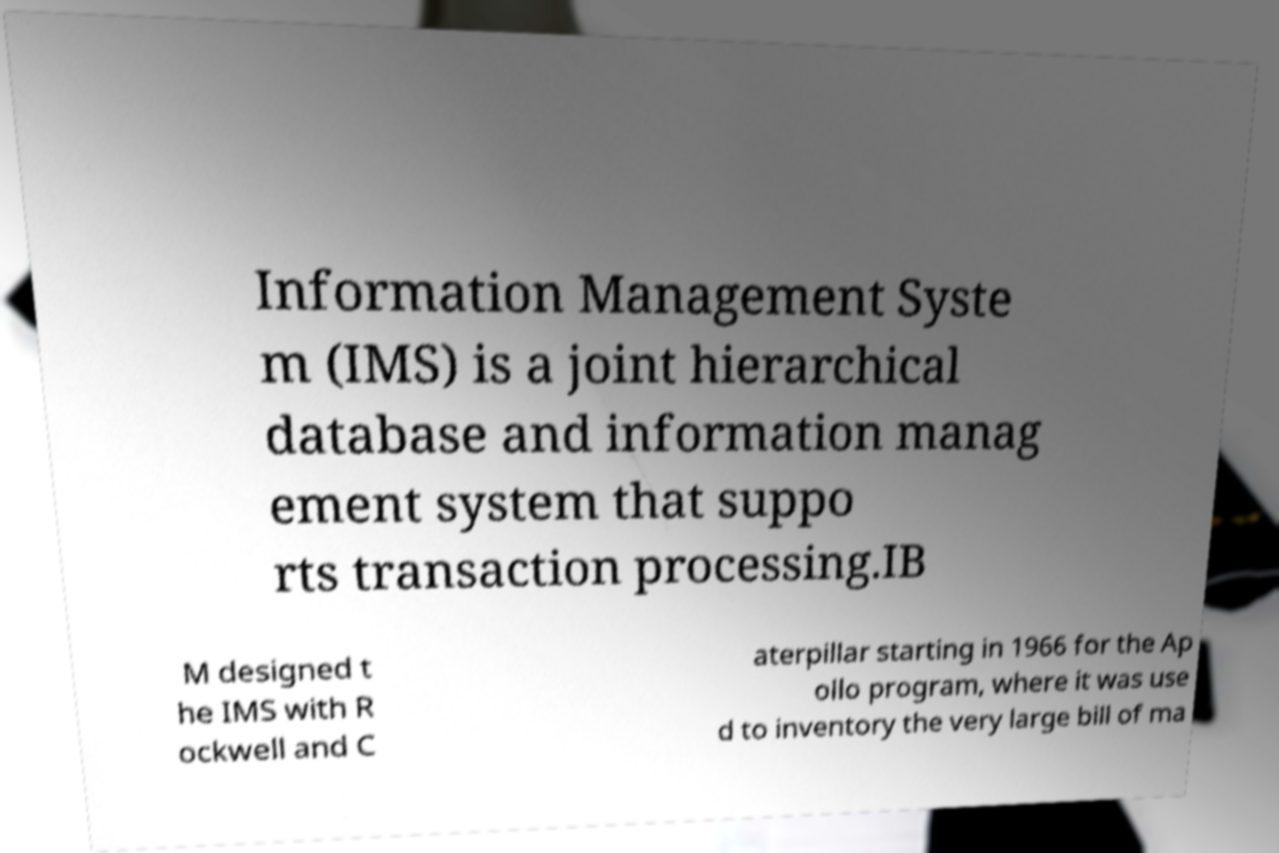I need the written content from this picture converted into text. Can you do that? Information Management Syste m (IMS) is a joint hierarchical database and information manag ement system that suppo rts transaction processing.IB M designed t he IMS with R ockwell and C aterpillar starting in 1966 for the Ap ollo program, where it was use d to inventory the very large bill of ma 